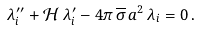Convert formula to latex. <formula><loc_0><loc_0><loc_500><loc_500>\lambda _ { i } ^ { \prime \prime } + \mathcal { H } \, \lambda _ { i } ^ { \prime } - 4 \pi \, \overline { \sigma } \, a ^ { 2 } \, \lambda _ { i } = 0 \, .</formula> 